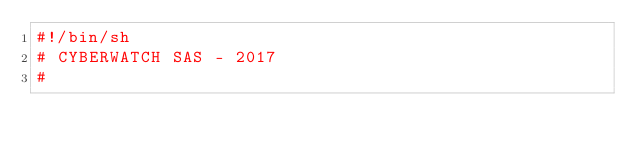Convert code to text. <code><loc_0><loc_0><loc_500><loc_500><_Bash_>#!/bin/sh
# CYBERWATCH SAS - 2017
#</code> 